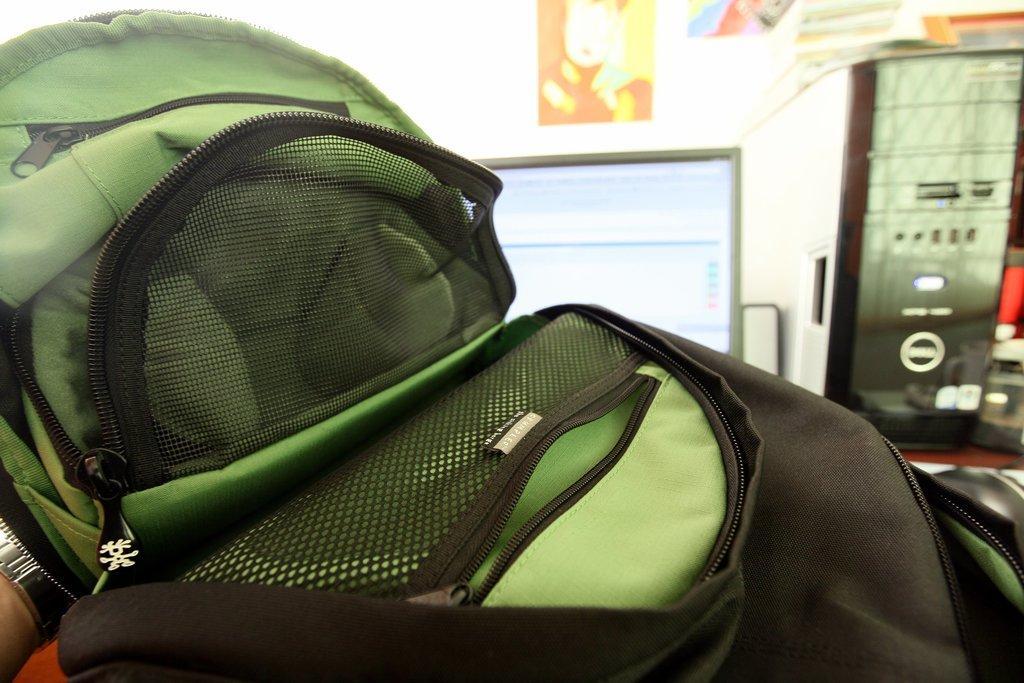Could you give a brief overview of what you see in this image? This is the picture of a bag which is in green and black color. Background of this bag is a monitor and a wall on the wall there are the posters. 